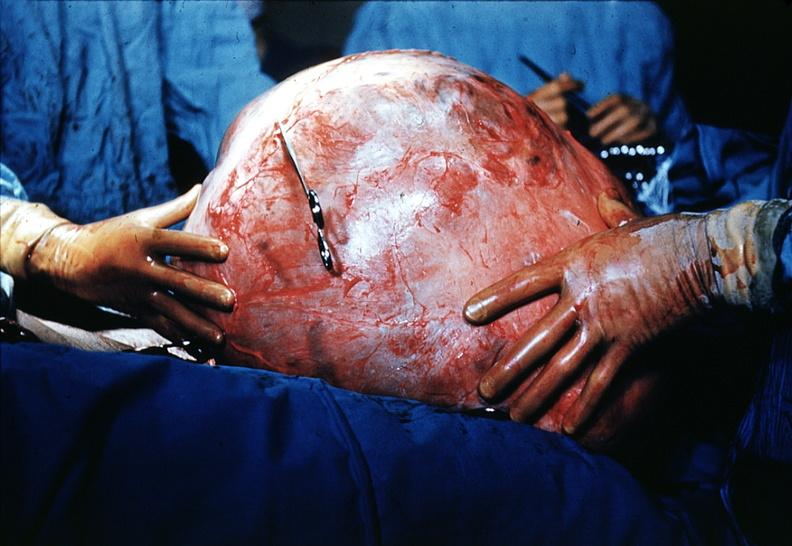s polycystic disease present?
Answer the question using a single word or phrase. No 